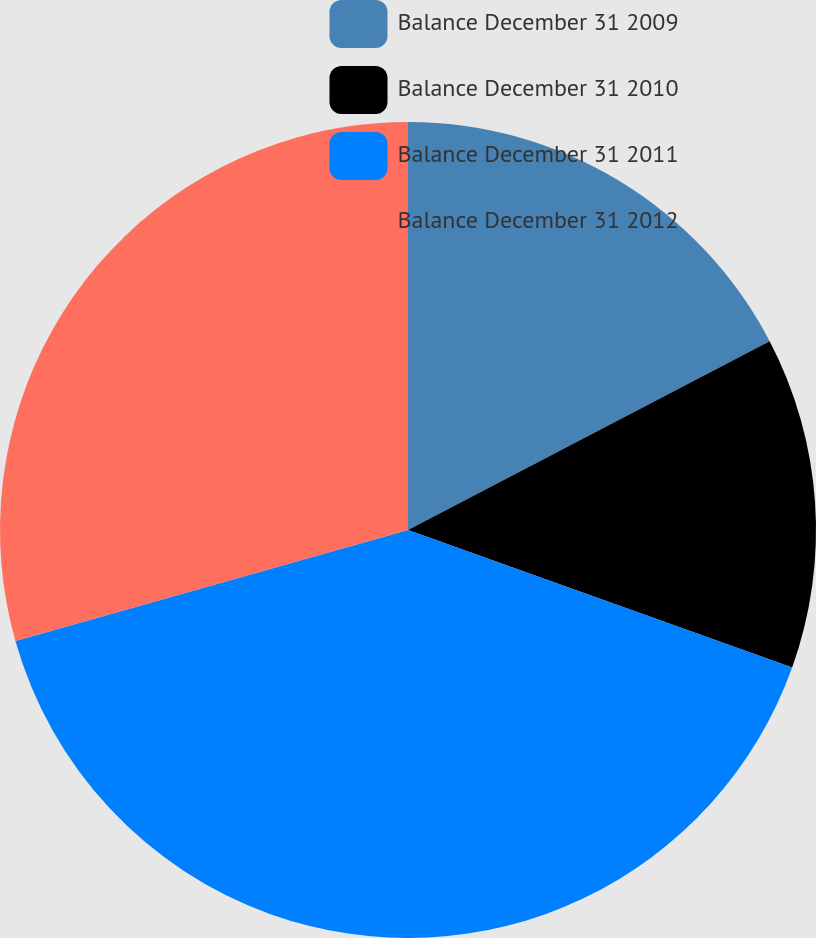<chart> <loc_0><loc_0><loc_500><loc_500><pie_chart><fcel>Balance December 31 2009<fcel>Balance December 31 2010<fcel>Balance December 31 2011<fcel>Balance December 31 2012<nl><fcel>17.34%<fcel>13.13%<fcel>40.14%<fcel>29.39%<nl></chart> 